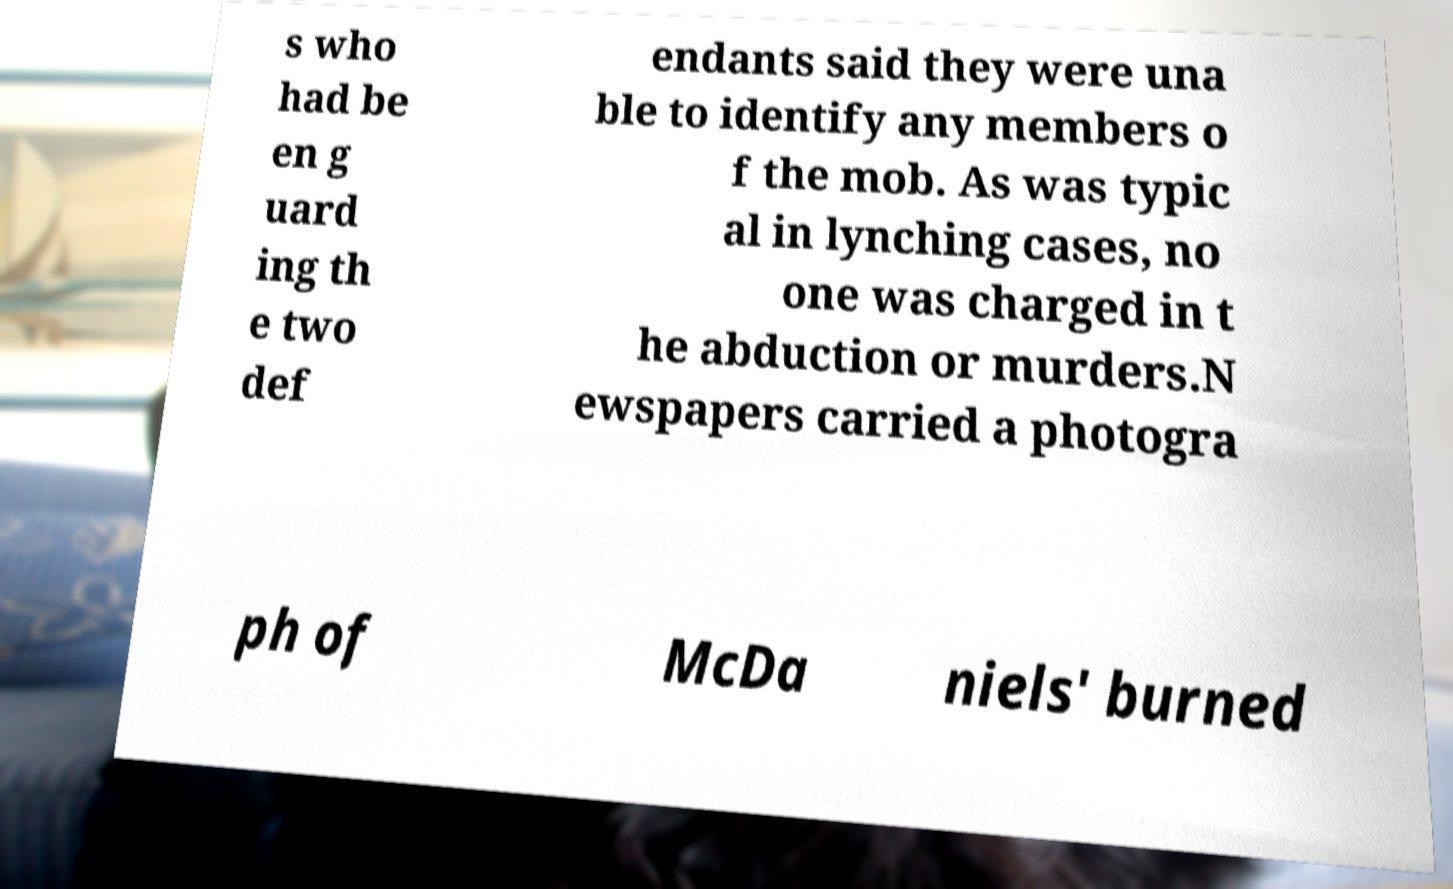Could you extract and type out the text from this image? s who had be en g uard ing th e two def endants said they were una ble to identify any members o f the mob. As was typic al in lynching cases, no one was charged in t he abduction or murders.N ewspapers carried a photogra ph of McDa niels' burned 